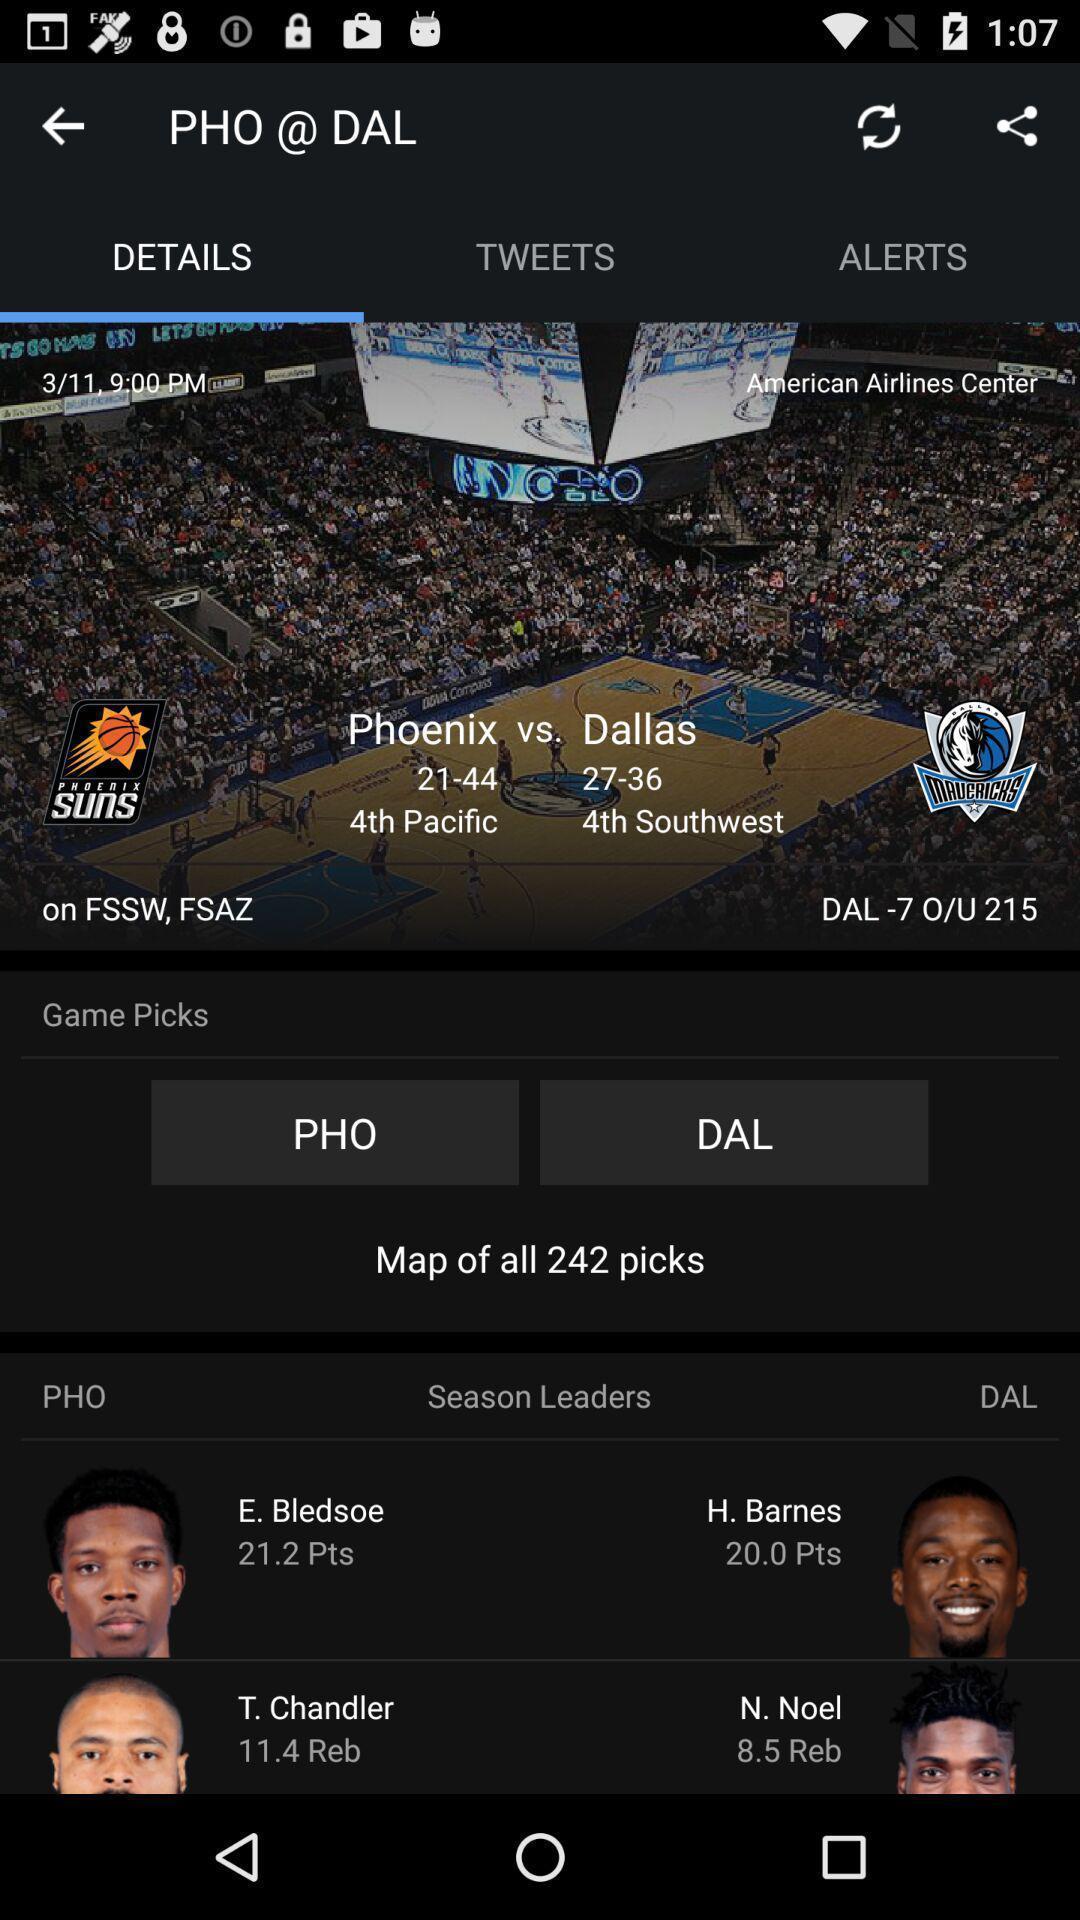Tell me about the visual elements in this screen capture. Screen displaying multiple team names with logos. 